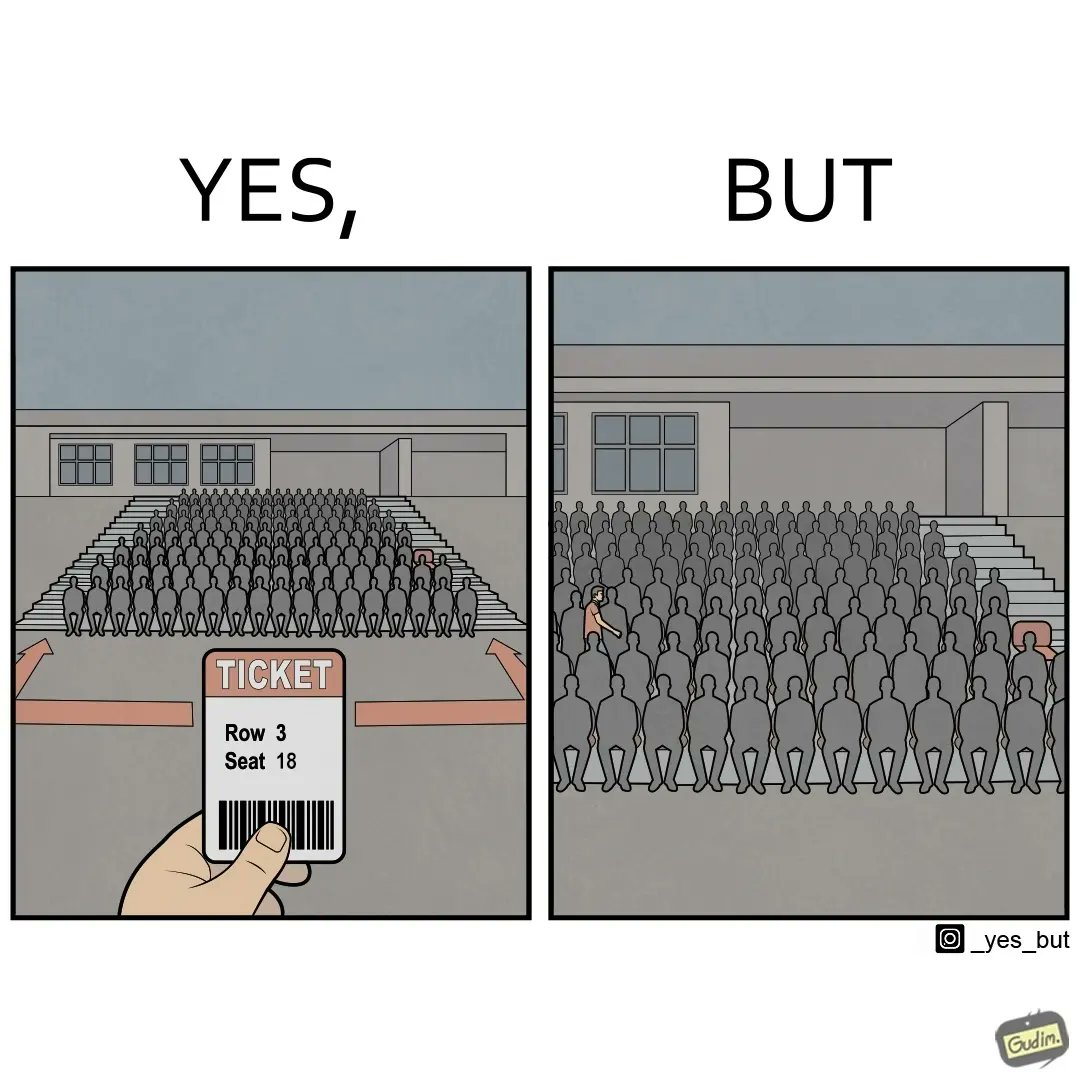Describe the content of this image. The image is funny, as the person has a ticket of a seat that is on the leftmost end of the gallery. However, the person has entered from the other end, and is going through a sea of seated people to get to the vacant seat. This would cause inconvenience to the people in the row, and would probably take a longer time to reach the seat. 